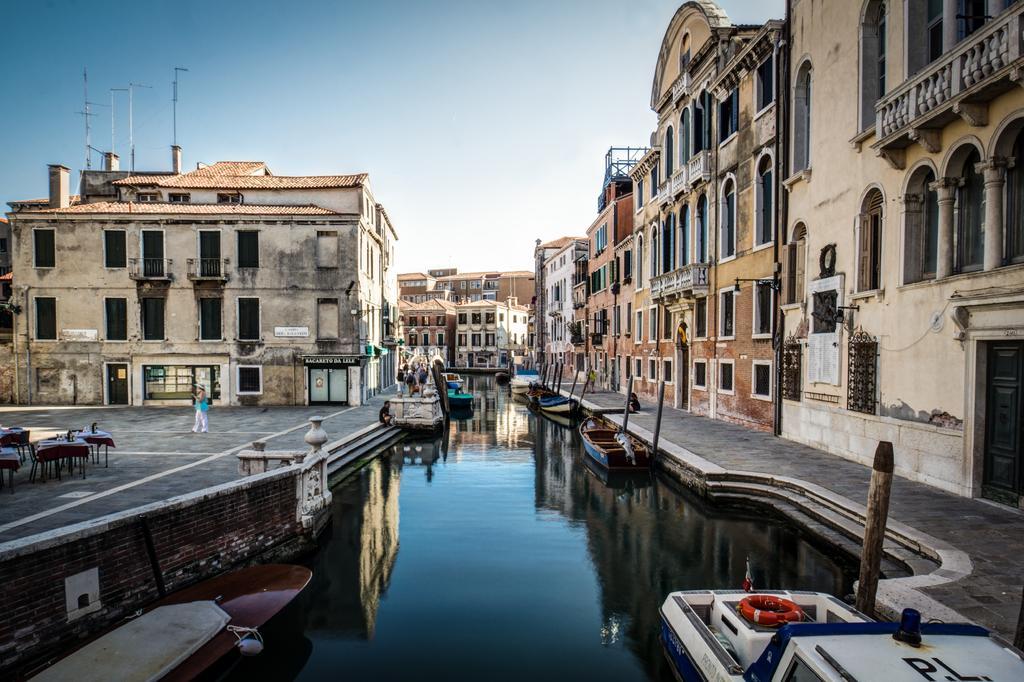How would you summarize this image in a sentence or two? In this picture we can see boats on water, swim tube, tables, poles, buildings with windows and a group of people walking on a path were a person sitting on the steps and in the background we can see the sky. 